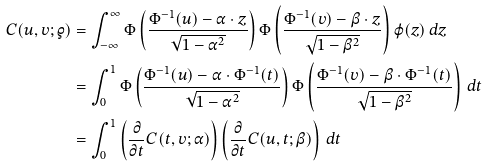Convert formula to latex. <formula><loc_0><loc_0><loc_500><loc_500>C ( u , v ; \varrho ) & = \int _ { - \infty } ^ { \infty } \Phi \left ( \frac { \Phi ^ { - 1 } ( u ) - \alpha \cdot z } { \sqrt { 1 - \alpha ^ { 2 } } } \right ) \Phi \left ( \frac { \Phi ^ { - 1 } ( v ) - \beta \cdot z } { \sqrt { 1 - \beta ^ { 2 } } } \right ) \varphi ( z ) \, d z \\ & = \int _ { 0 } ^ { 1 } \Phi \left ( \frac { \Phi ^ { - 1 } ( u ) - \alpha \cdot \Phi ^ { - 1 } ( t ) } { \sqrt { 1 - \alpha ^ { 2 } } } \right ) \Phi \left ( \frac { \Phi ^ { - 1 } ( v ) - \beta \cdot \Phi ^ { - 1 } ( t ) } { \sqrt { 1 - \beta ^ { 2 } } } \right ) \, d t \\ & = \int _ { 0 } ^ { 1 } \left ( \frac { \partial } { \partial t } C ( t , v ; \alpha ) \right ) \left ( \frac { \partial } { \partial t } C ( u , t ; \beta ) \right ) \, d t</formula> 